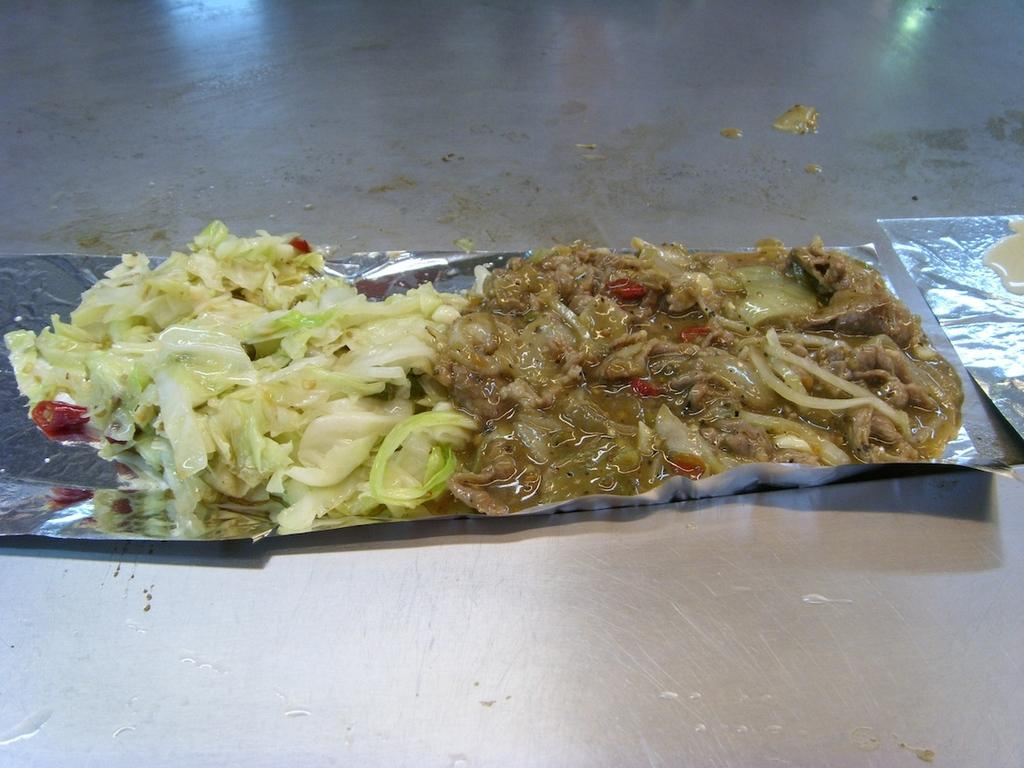What is the main subject of the image? The main subject of the image is food. How is the food being presented or contained in the image? The food is on a cover. How many pies are visible on the cover in the image? There is no information about pies in the image; it only mentions that there is food on a cover. Can you see a snake slithering around the food on the cover in the image? There is no snake present in the image. 